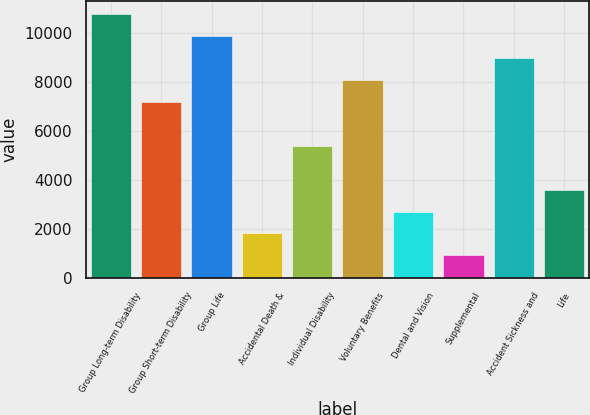Convert chart to OTSL. <chart><loc_0><loc_0><loc_500><loc_500><bar_chart><fcel>Group Long-term Disability<fcel>Group Short-term Disability<fcel>Group Life<fcel>Accidental Death &<fcel>Individual Disability<fcel>Voluntary Benefits<fcel>Dental and Vision<fcel>Supplemental<fcel>Accident Sickness and<fcel>Life<nl><fcel>10781.7<fcel>7190.48<fcel>9883.91<fcel>1803.62<fcel>5394.86<fcel>8088.29<fcel>2701.43<fcel>905.81<fcel>8986.1<fcel>3599.24<nl></chart> 